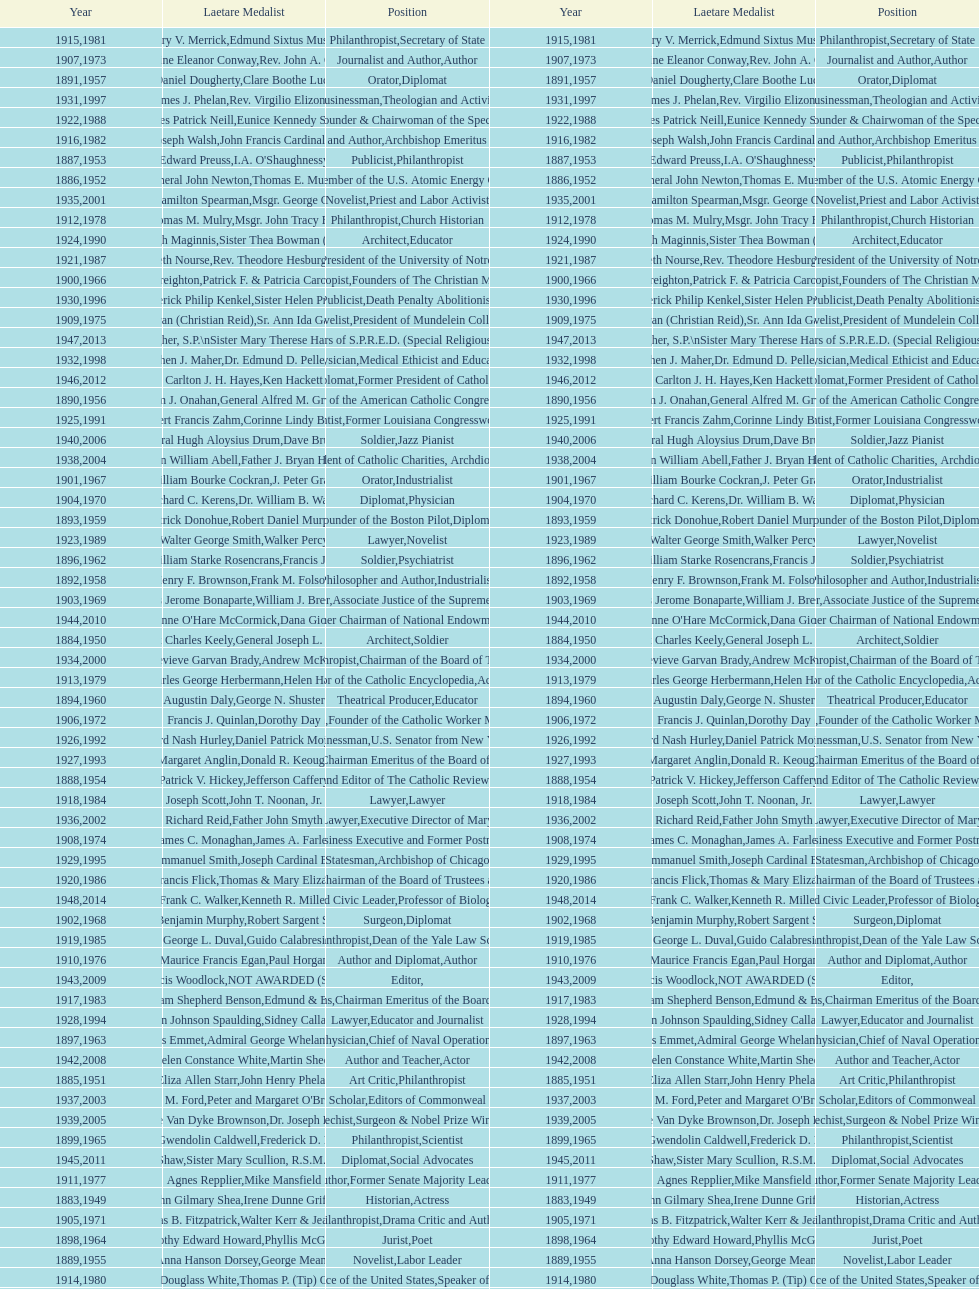How many laetare medalists were philantrohpists? 2. 